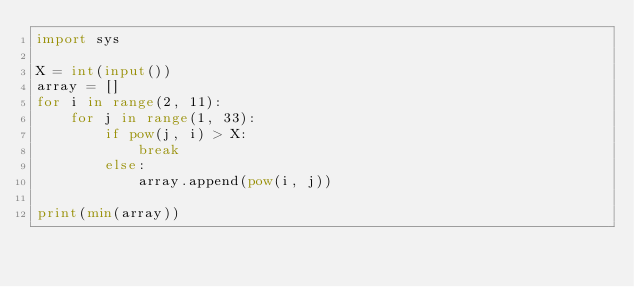Convert code to text. <code><loc_0><loc_0><loc_500><loc_500><_Python_>import sys

X = int(input())
array = []
for i in range(2, 11):
    for j in range(1, 33):
        if pow(j, i) > X:
            break
        else:
            array.append(pow(i, j))
        
print(min(array))</code> 